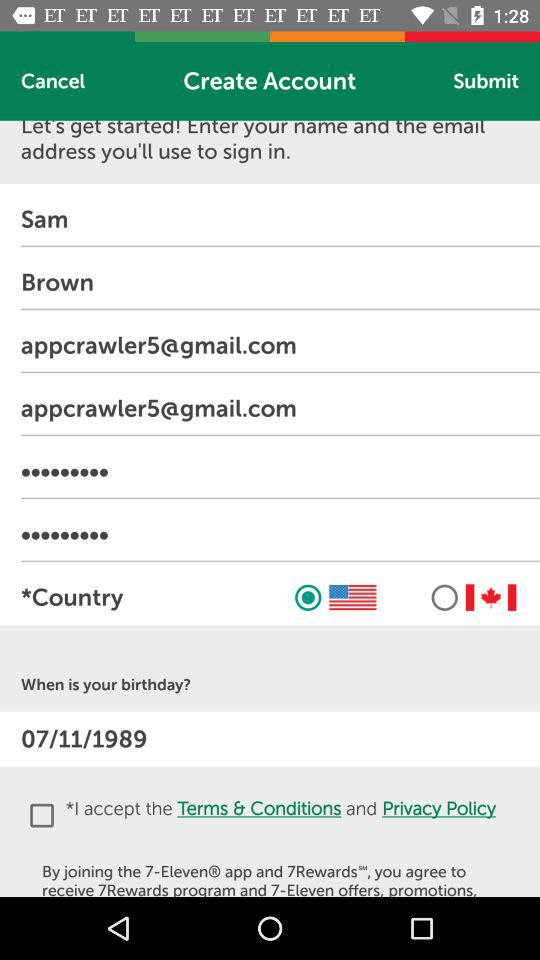What are the requirements for the password?
When the provided information is insufficient, respond with <no answer>. <no answer> 